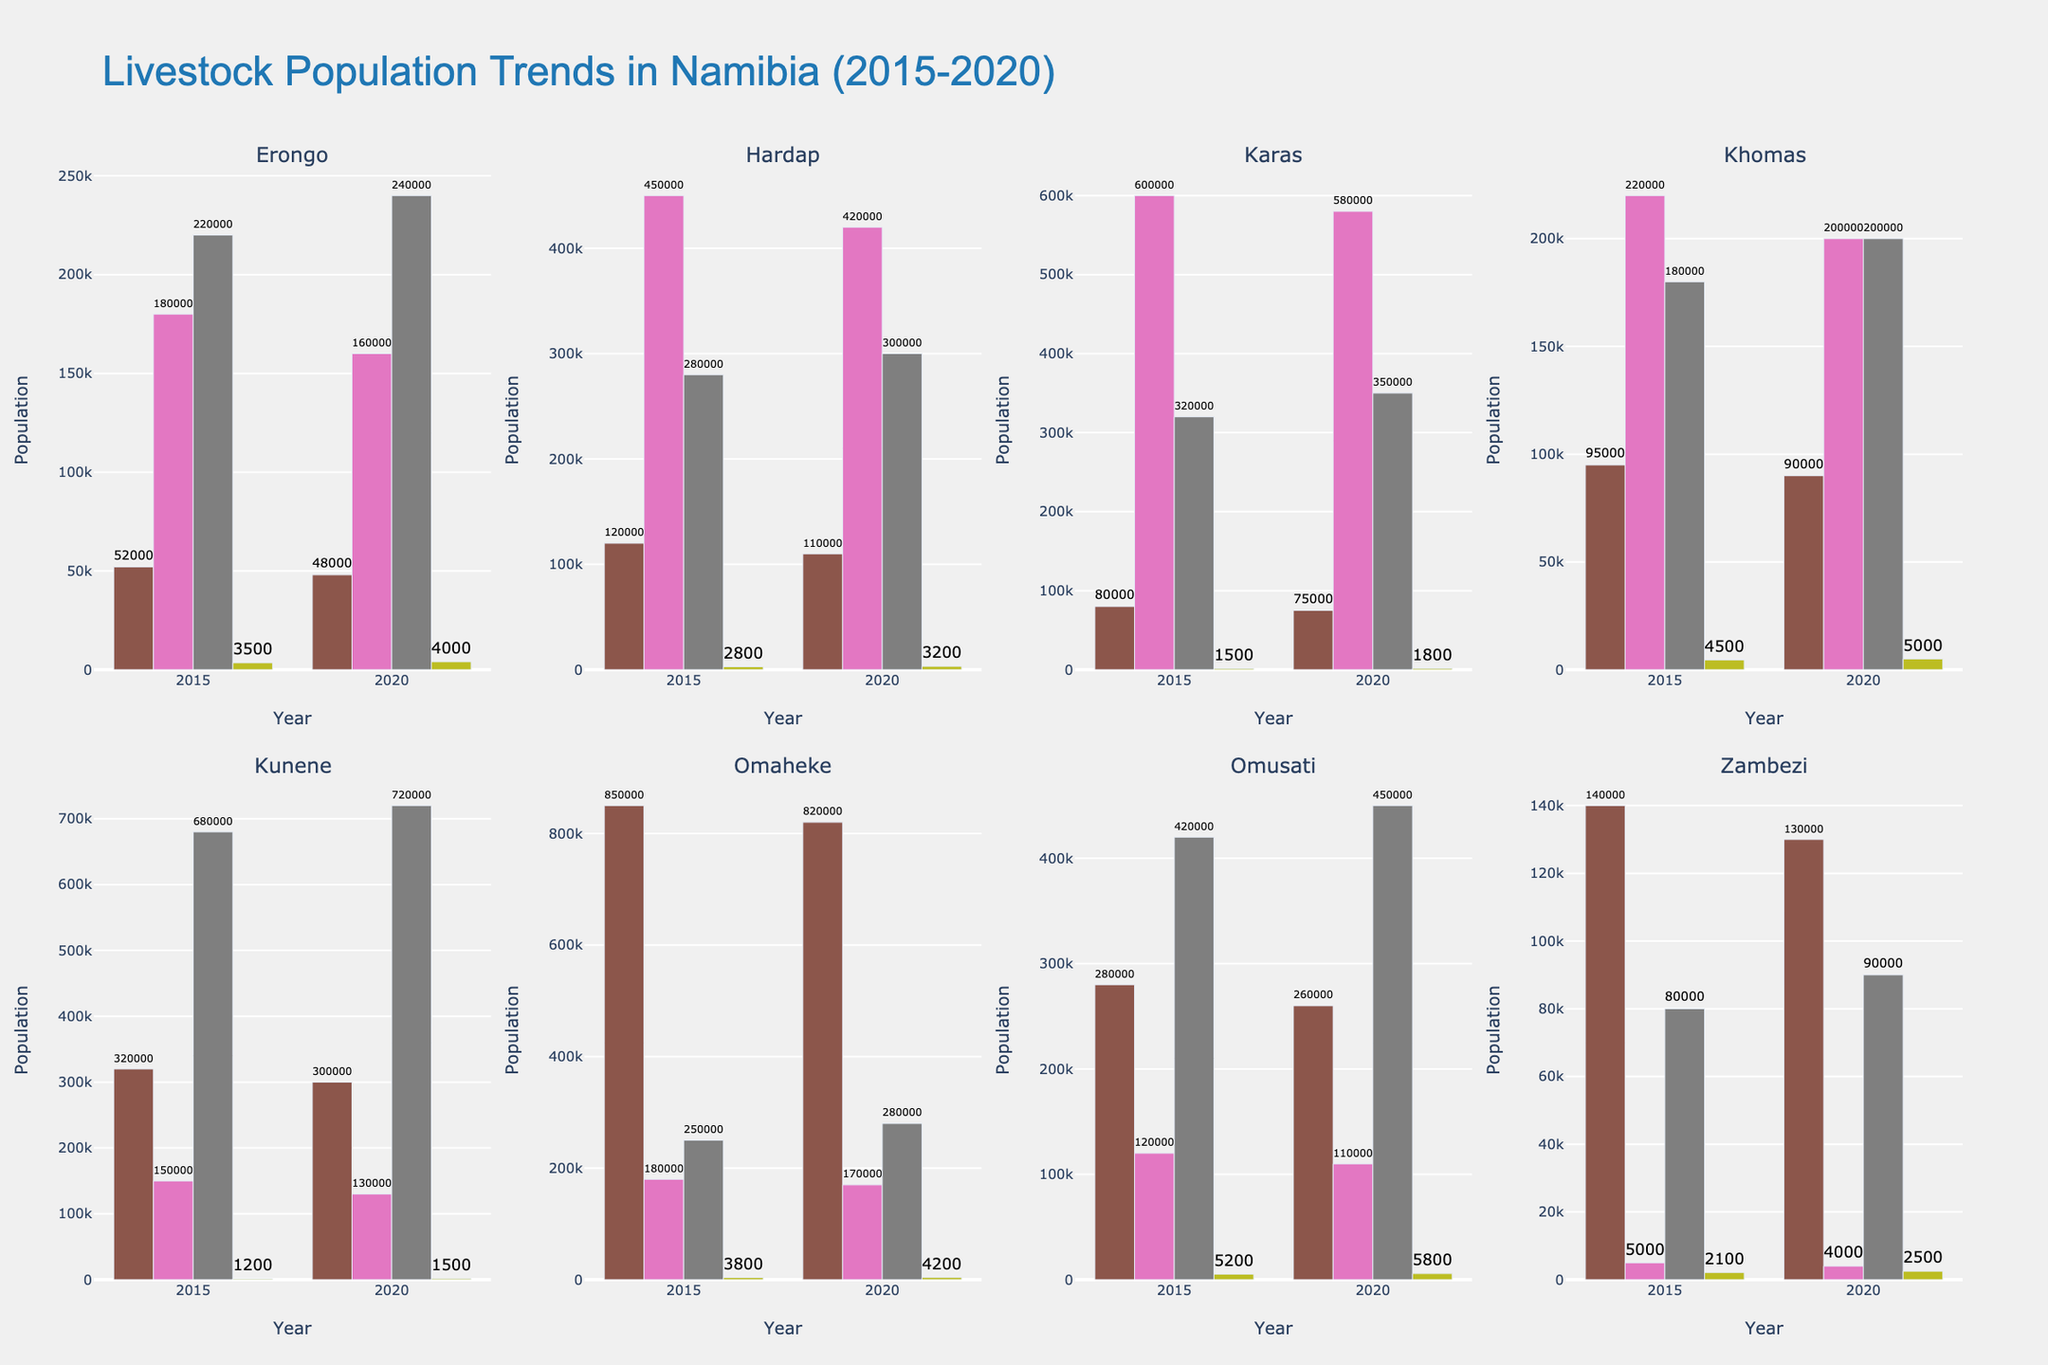How much did the cattle population in Kunene decrease from 2015 to 2020? In the subplot for Kunene, observe the height of the bars for cattle in the years 2015 and 2020. The population decreased from 320,000 in 2015 to 300,000 in 2020. Therefore, the decrease is 320,000 - 300,000 = 20,000
Answer: 20,000 Which region had the highest goat population in 2020? Look at the bars representing the goat population across all subplots for the year 2020. Kunene had the tallest bar for goats, indicating the highest population, with 720,000
Answer: Kunene What is the total pig population in 2015 combining all regions? Add the pig populations for all regions in 2015: Erongo (3500), Hardap (2800), Karas (1500), Khomas (4500), Kunene (1200), Omaheke (3800), Omusati (5200), Zambezi (2100). The total is 3500 + 2800 + 1500 + 4500 + 1200 + 3800 + 5200 + 2100 = 24600
Answer: 24,600 Which region saw a decrease in the sheep population between 2015 and 2020? Compare the sheep population bars between 2015 and 2020 for each region. Both Erongo and Hardap saw a decrease from 2015 to 2020 (Erongo: 180,000 to 160,000, Hardap: 450,000 to 420,000, Karas: 600,000 to 580,000, Kunene: 150,000 to 130,000, Omaheke: 180,000 to 170,000, Omusati: 120,000 to 110,000, Zambezi: 5,000 to 4,000)
Answer: Erongo, Hardap, Karas, Kunene, Omaheke, Omusati, Zambezi What is the average cattle population for Khomas across 2015 and 2020? Find the cattle population for Khomas in 2015 (95,000) and 2020 (90,000). Average them by (95,000 + 90,000) / 2 = 92,500
Answer: 92,500 How did the goat population trend in Erongo from 2015 to 2020? Observe the height of the bars for the goat population in Erongo for the years 2015 and 2020. The population increased from 220,000 to 240,000, indicating an upward trend
Answer: Increased Which region had the smallest pig population in 2015? Check the bars for the pig population in 2015 across all regions. Kunene's pig population was the smallest with 1,200
Answer: Kunene For Omusati, what’s the difference in sheep population between 2015 and 2020? Look at the bars for the sheep population in Omusati for 2015 and 2020. The population decreased from 120,000 to 110,000. Therefore, the difference is 120,000 - 110,000 = 10,000
Answer: 10,000 Which livestock showed a consistent population increase in Omaheke from 2015 to 2020? Examine the bars for each type of livestock in Omaheke. The pigs and cattle populations showed an increase from 2015 to 2020 (cattle: 850,000 to 820,000, pigs: 3,800 to 4,200)
Answer: Pigs, Cattle 